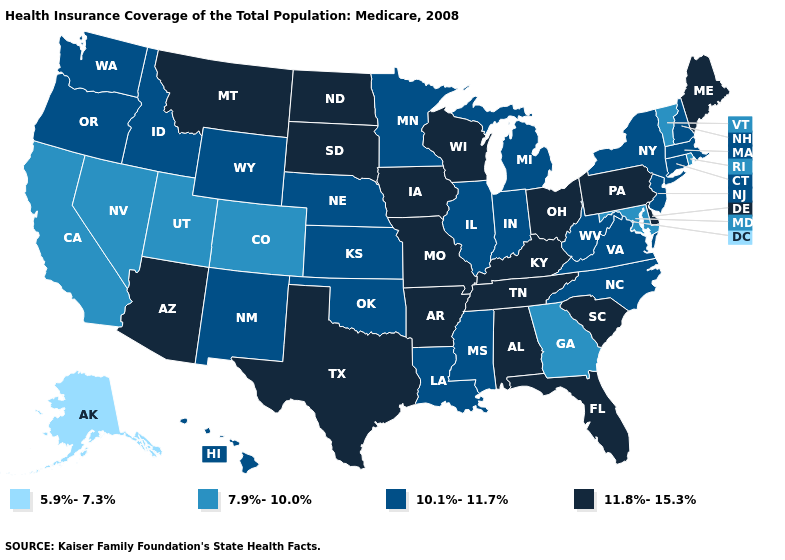Among the states that border South Carolina , which have the lowest value?
Short answer required. Georgia. Among the states that border North Carolina , which have the lowest value?
Give a very brief answer. Georgia. Does Wisconsin have the same value as Illinois?
Short answer required. No. Does the map have missing data?
Concise answer only. No. Name the states that have a value in the range 11.8%-15.3%?
Be succinct. Alabama, Arizona, Arkansas, Delaware, Florida, Iowa, Kentucky, Maine, Missouri, Montana, North Dakota, Ohio, Pennsylvania, South Carolina, South Dakota, Tennessee, Texas, Wisconsin. What is the highest value in the USA?
Quick response, please. 11.8%-15.3%. Which states have the lowest value in the USA?
Short answer required. Alaska. Which states have the lowest value in the USA?
Short answer required. Alaska. What is the lowest value in the USA?
Be succinct. 5.9%-7.3%. Name the states that have a value in the range 5.9%-7.3%?
Concise answer only. Alaska. What is the highest value in the USA?
Short answer required. 11.8%-15.3%. Name the states that have a value in the range 11.8%-15.3%?
Short answer required. Alabama, Arizona, Arkansas, Delaware, Florida, Iowa, Kentucky, Maine, Missouri, Montana, North Dakota, Ohio, Pennsylvania, South Carolina, South Dakota, Tennessee, Texas, Wisconsin. Name the states that have a value in the range 10.1%-11.7%?
Write a very short answer. Connecticut, Hawaii, Idaho, Illinois, Indiana, Kansas, Louisiana, Massachusetts, Michigan, Minnesota, Mississippi, Nebraska, New Hampshire, New Jersey, New Mexico, New York, North Carolina, Oklahoma, Oregon, Virginia, Washington, West Virginia, Wyoming. Name the states that have a value in the range 11.8%-15.3%?
Give a very brief answer. Alabama, Arizona, Arkansas, Delaware, Florida, Iowa, Kentucky, Maine, Missouri, Montana, North Dakota, Ohio, Pennsylvania, South Carolina, South Dakota, Tennessee, Texas, Wisconsin. 